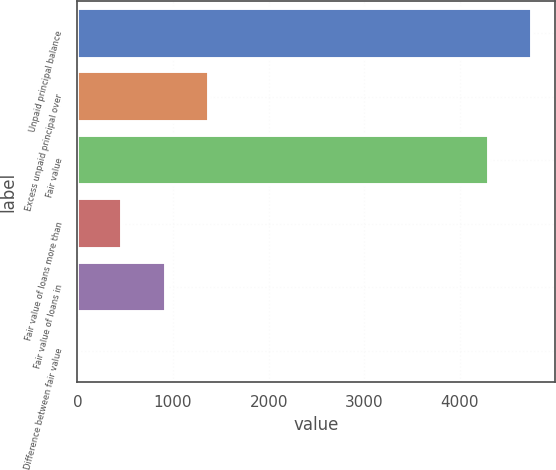<chart> <loc_0><loc_0><loc_500><loc_500><bar_chart><fcel>Unpaid principal balance<fcel>Excess unpaid principal over<fcel>Fair value<fcel>Fair value of loans more than<fcel>Fair value of loans in<fcel>Difference between fair value<nl><fcel>4757.2<fcel>1375.6<fcel>4304<fcel>469.2<fcel>922.4<fcel>16<nl></chart> 